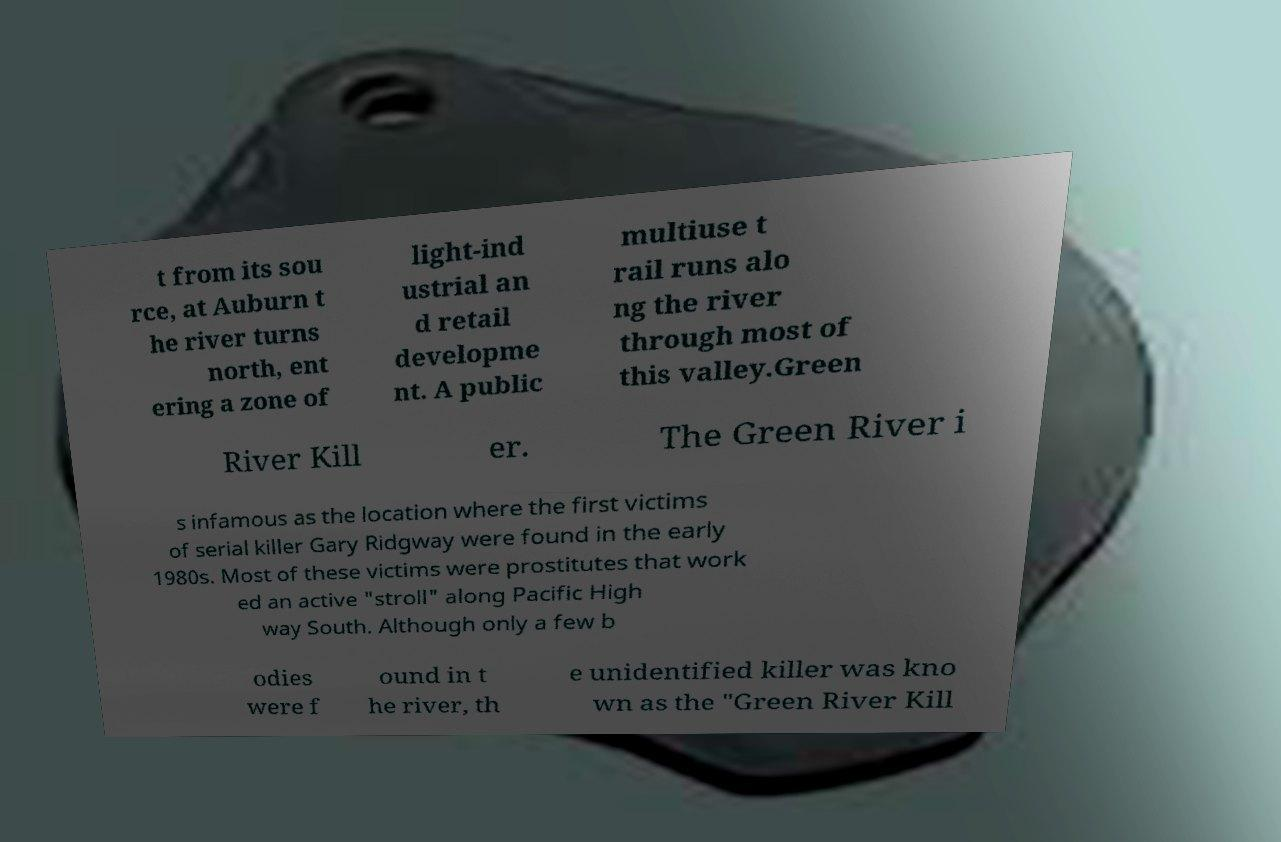Please read and relay the text visible in this image. What does it say? t from its sou rce, at Auburn t he river turns north, ent ering a zone of light-ind ustrial an d retail developme nt. A public multiuse t rail runs alo ng the river through most of this valley.Green River Kill er. The Green River i s infamous as the location where the first victims of serial killer Gary Ridgway were found in the early 1980s. Most of these victims were prostitutes that work ed an active "stroll" along Pacific High way South. Although only a few b odies were f ound in t he river, th e unidentified killer was kno wn as the "Green River Kill 